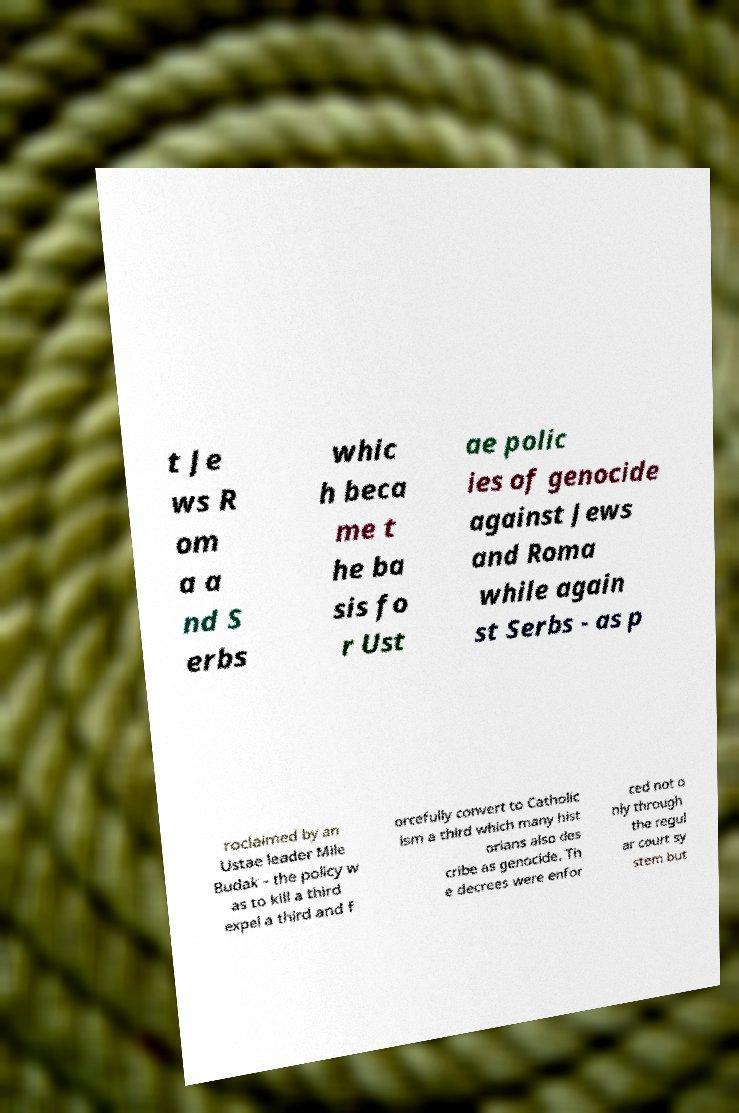Please read and relay the text visible in this image. What does it say? t Je ws R om a a nd S erbs whic h beca me t he ba sis fo r Ust ae polic ies of genocide against Jews and Roma while again st Serbs - as p roclaimed by an Ustae leader Mile Budak - the policy w as to kill a third expel a third and f orcefully convert to Catholic ism a third which many hist orians also des cribe as genocide. Th e decrees were enfor ced not o nly through the regul ar court sy stem but 